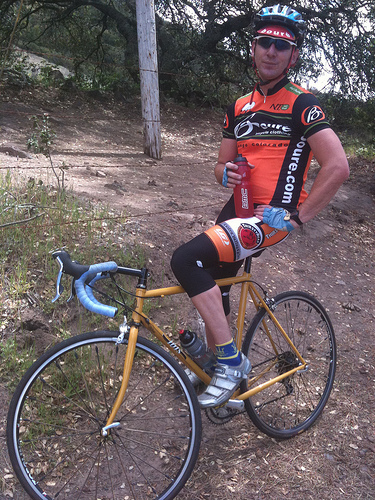<image>
Can you confirm if the boy is on the bicycle? Yes. Looking at the image, I can see the boy is positioned on top of the bicycle, with the bicycle providing support. 